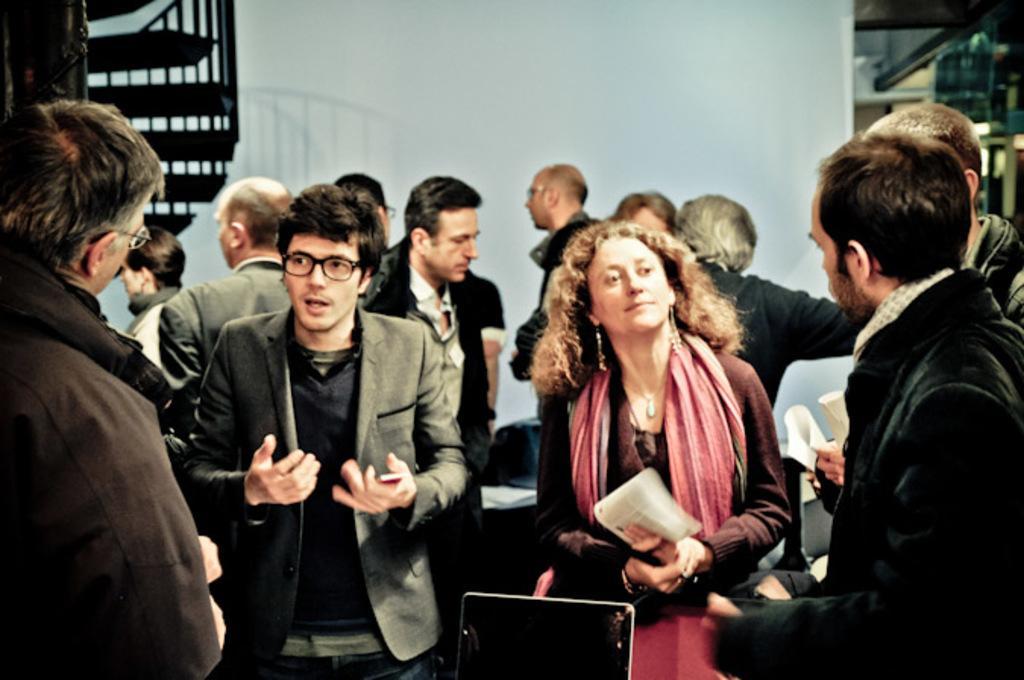Can you describe this image briefly? In this image there is a woman wearing a scarf. Before her there is a laptop. Beside her there is a person wearing spectacles. There are people on the floor. Left top there is a staircase. Background there is a wall. 